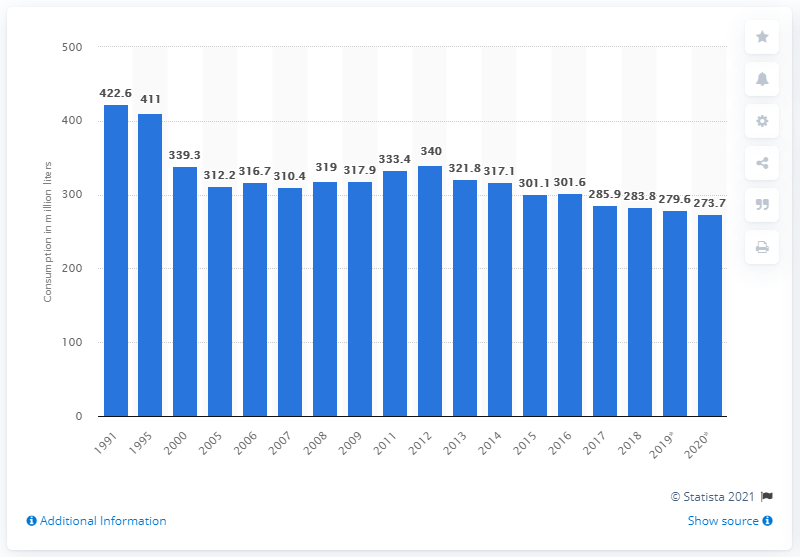Outline some significant characteristics in this image. In 2020, a total of 273.7 million liters of sparkling wine was consumed in Germany. 